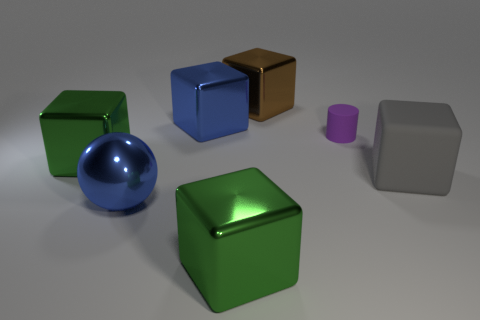Subtract all gray blocks. How many blocks are left? 4 Subtract all rubber cubes. How many cubes are left? 4 Subtract all yellow cubes. Subtract all yellow cylinders. How many cubes are left? 5 Add 1 large purple metallic cylinders. How many objects exist? 8 Subtract all cylinders. How many objects are left? 6 Subtract all large blue metal balls. Subtract all gray matte blocks. How many objects are left? 5 Add 5 blue things. How many blue things are left? 7 Add 6 big blue balls. How many big blue balls exist? 7 Subtract 0 brown cylinders. How many objects are left? 7 